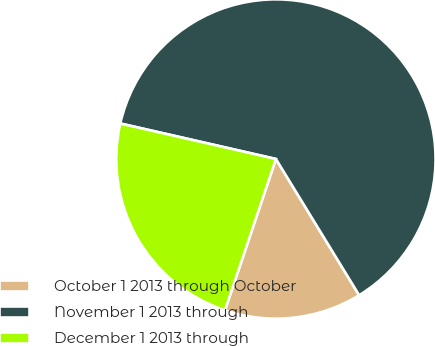Convert chart to OTSL. <chart><loc_0><loc_0><loc_500><loc_500><pie_chart><fcel>October 1 2013 through October<fcel>November 1 2013 through<fcel>December 1 2013 through<nl><fcel>13.9%<fcel>62.7%<fcel>23.4%<nl></chart> 